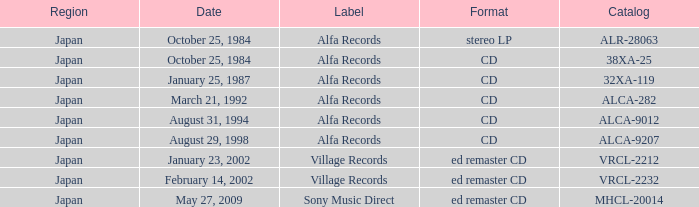What is the region of the release of a CD with catalog 32xa-119? Japan. 